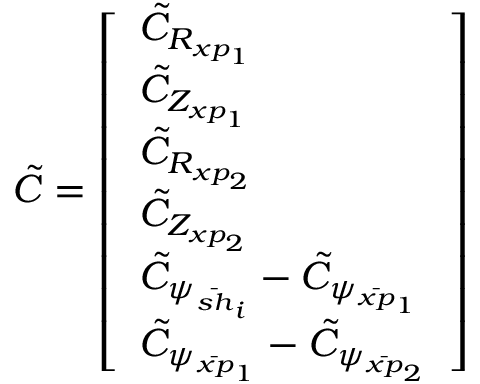Convert formula to latex. <formula><loc_0><loc_0><loc_500><loc_500>\tilde { C } = \left [ \begin{array} { l } { \tilde { C } _ { R _ { x p _ { 1 } } } } \\ { \tilde { C } _ { Z _ { x p _ { 1 } } } } \\ { \tilde { C } _ { R _ { x p _ { 2 } } } } \\ { \tilde { C } _ { Z _ { x p _ { 2 } } } } \\ { \tilde { C } _ { \psi _ { \bar { s h } _ { i } } } - \tilde { C } _ { \psi _ { \bar { x p } _ { 1 } } } } \\ { \tilde { C } _ { \psi _ { \bar { x p } _ { 1 } } } - \tilde { C } _ { \psi _ { \bar { x p } _ { 2 } } } } \end{array} \right ]</formula> 